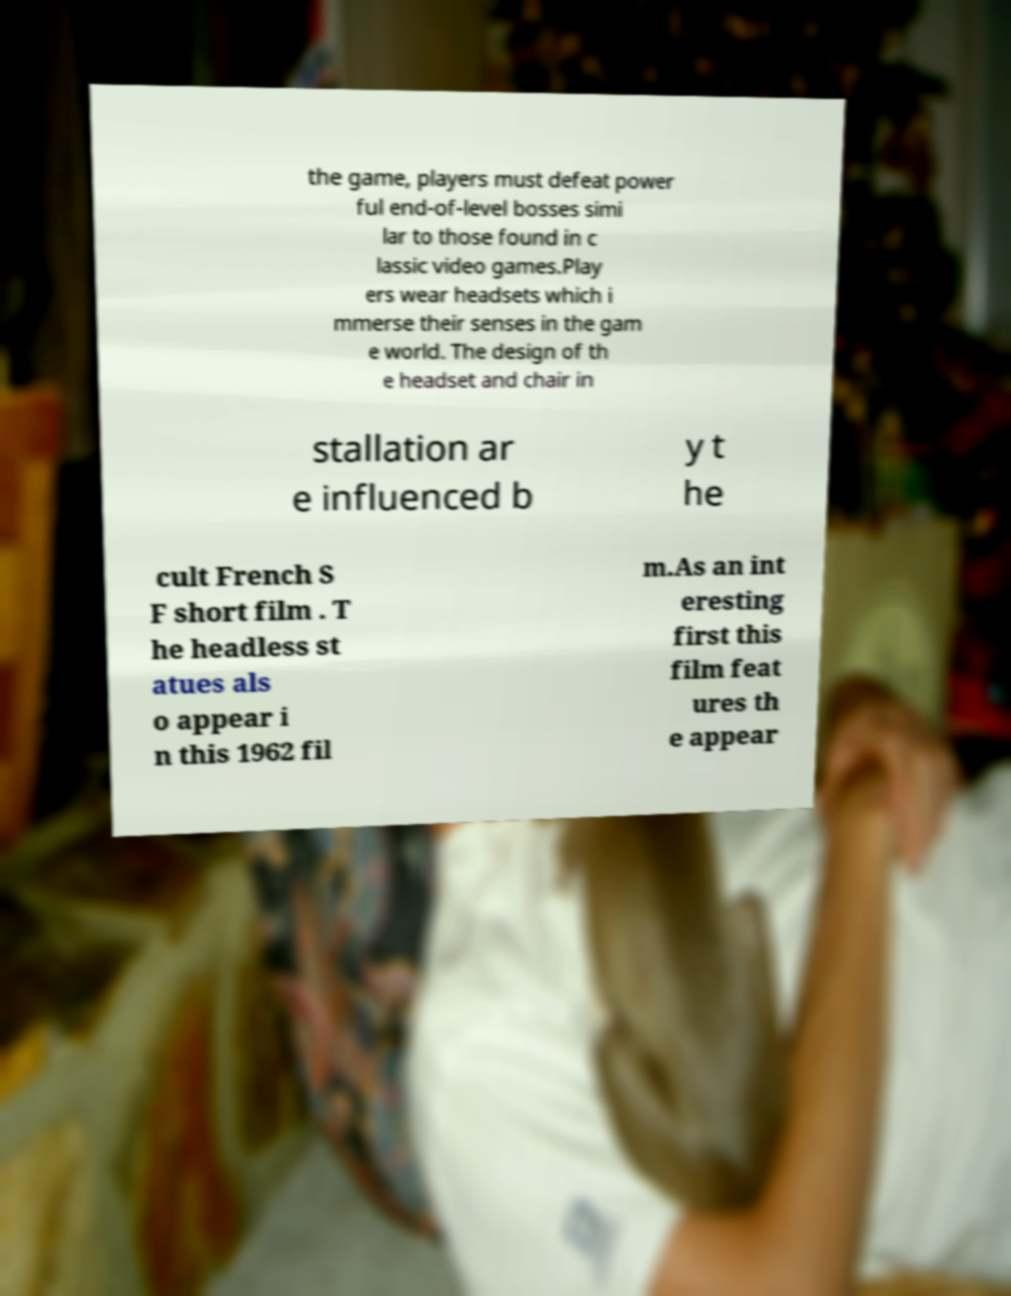I need the written content from this picture converted into text. Can you do that? the game, players must defeat power ful end-of-level bosses simi lar to those found in c lassic video games.Play ers wear headsets which i mmerse their senses in the gam e world. The design of th e headset and chair in stallation ar e influenced b y t he cult French S F short film . T he headless st atues als o appear i n this 1962 fil m.As an int eresting first this film feat ures th e appear 